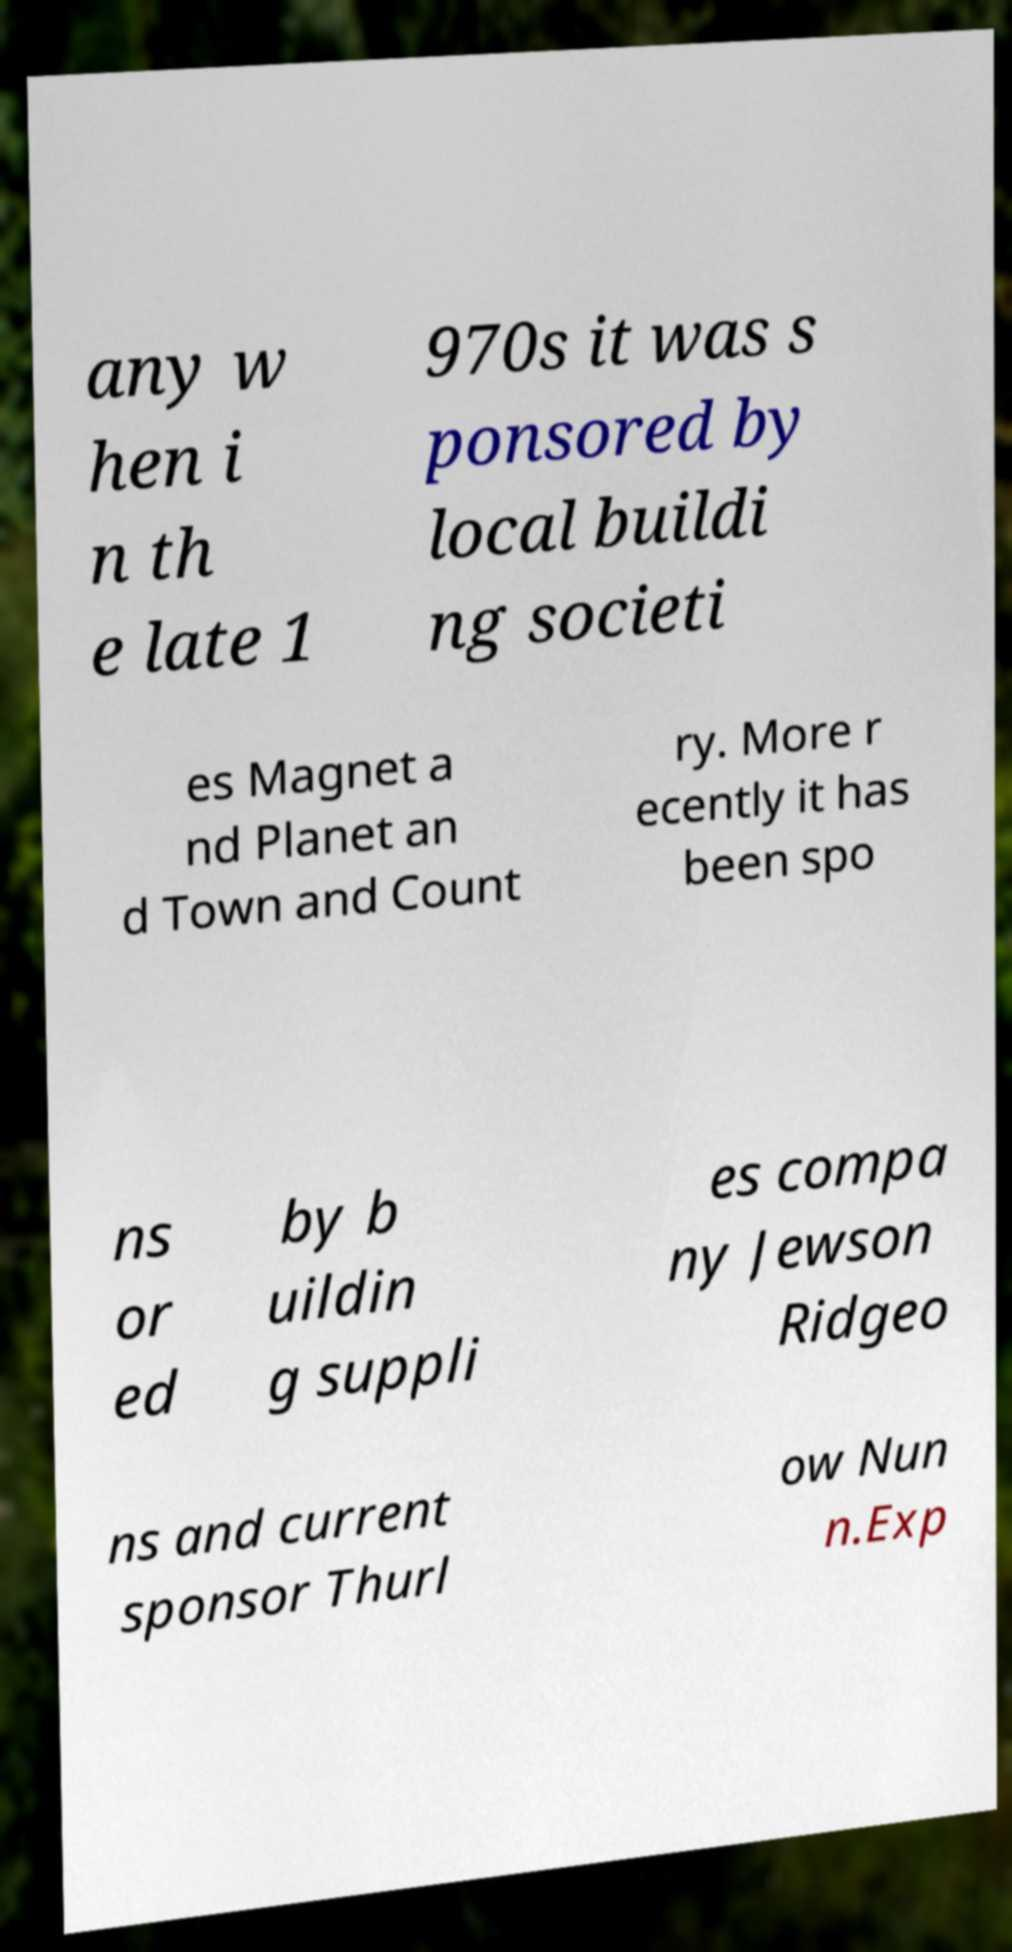For documentation purposes, I need the text within this image transcribed. Could you provide that? any w hen i n th e late 1 970s it was s ponsored by local buildi ng societi es Magnet a nd Planet an d Town and Count ry. More r ecently it has been spo ns or ed by b uildin g suppli es compa ny Jewson Ridgeo ns and current sponsor Thurl ow Nun n.Exp 